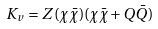<formula> <loc_0><loc_0><loc_500><loc_500>K _ { v } = Z ( \chi \bar { \chi } ) ( \chi \bar { \chi } + Q \bar { Q } )</formula> 